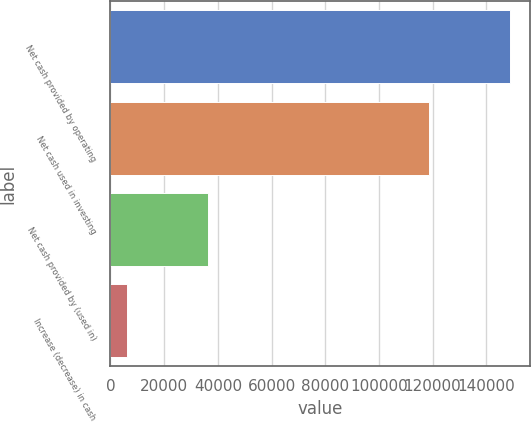<chart> <loc_0><loc_0><loc_500><loc_500><bar_chart><fcel>Net cash provided by operating<fcel>Net cash used in investing<fcel>Net cash provided by (used in)<fcel>Increase (decrease) in cash<nl><fcel>148958<fcel>118807<fcel>36293<fcel>6142<nl></chart> 